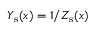<formula> <loc_0><loc_0><loc_500><loc_500>Y _ { s } ( x ) = 1 / Z _ { s } ( x )</formula> 